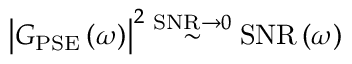Convert formula to latex. <formula><loc_0><loc_0><loc_500><loc_500>\left | G _ { P S E } \left ( \omega \right ) \right | ^ { 2 } \stackrel { S N R \to 0 } { \sim } S N R \left ( \omega \right )</formula> 